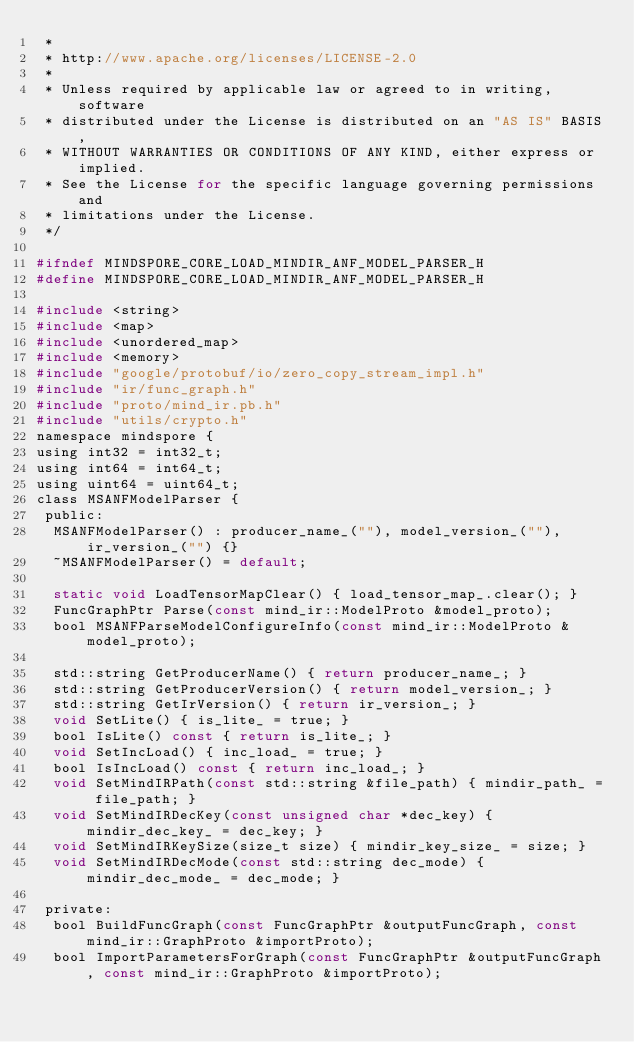<code> <loc_0><loc_0><loc_500><loc_500><_C_> *
 * http://www.apache.org/licenses/LICENSE-2.0
 *
 * Unless required by applicable law or agreed to in writing, software
 * distributed under the License is distributed on an "AS IS" BASIS,
 * WITHOUT WARRANTIES OR CONDITIONS OF ANY KIND, either express or implied.
 * See the License for the specific language governing permissions and
 * limitations under the License.
 */

#ifndef MINDSPORE_CORE_LOAD_MINDIR_ANF_MODEL_PARSER_H
#define MINDSPORE_CORE_LOAD_MINDIR_ANF_MODEL_PARSER_H

#include <string>
#include <map>
#include <unordered_map>
#include <memory>
#include "google/protobuf/io/zero_copy_stream_impl.h"
#include "ir/func_graph.h"
#include "proto/mind_ir.pb.h"
#include "utils/crypto.h"
namespace mindspore {
using int32 = int32_t;
using int64 = int64_t;
using uint64 = uint64_t;
class MSANFModelParser {
 public:
  MSANFModelParser() : producer_name_(""), model_version_(""), ir_version_("") {}
  ~MSANFModelParser() = default;

  static void LoadTensorMapClear() { load_tensor_map_.clear(); }
  FuncGraphPtr Parse(const mind_ir::ModelProto &model_proto);
  bool MSANFParseModelConfigureInfo(const mind_ir::ModelProto &model_proto);

  std::string GetProducerName() { return producer_name_; }
  std::string GetProducerVersion() { return model_version_; }
  std::string GetIrVersion() { return ir_version_; }
  void SetLite() { is_lite_ = true; }
  bool IsLite() const { return is_lite_; }
  void SetIncLoad() { inc_load_ = true; }
  bool IsIncLoad() const { return inc_load_; }
  void SetMindIRPath(const std::string &file_path) { mindir_path_ = file_path; }
  void SetMindIRDecKey(const unsigned char *dec_key) { mindir_dec_key_ = dec_key; }
  void SetMindIRKeySize(size_t size) { mindir_key_size_ = size; }
  void SetMindIRDecMode(const std::string dec_mode) { mindir_dec_mode_ = dec_mode; }

 private:
  bool BuildFuncGraph(const FuncGraphPtr &outputFuncGraph, const mind_ir::GraphProto &importProto);
  bool ImportParametersForGraph(const FuncGraphPtr &outputFuncGraph, const mind_ir::GraphProto &importProto);</code> 